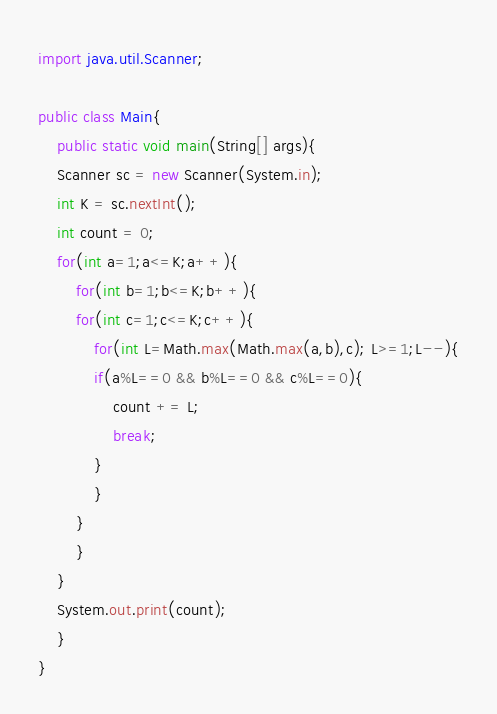Convert code to text. <code><loc_0><loc_0><loc_500><loc_500><_Java_>import java.util.Scanner;

public class Main{
    public static void main(String[] args){
	Scanner sc = new Scanner(System.in);
	int K = sc.nextInt();
	int count = 0;
	for(int a=1;a<=K;a++){
	    for(int b=1;b<=K;b++){
		for(int c=1;c<=K;c++){
		    for(int L=Math.max(Math.max(a,b),c); L>=1;L--){
			if(a%L==0 && b%L==0 && c%L==0){
			    count += L;
			    break;
			}
		    }
		}
	    }
	}
	System.out.print(count);
    }
}
</code> 